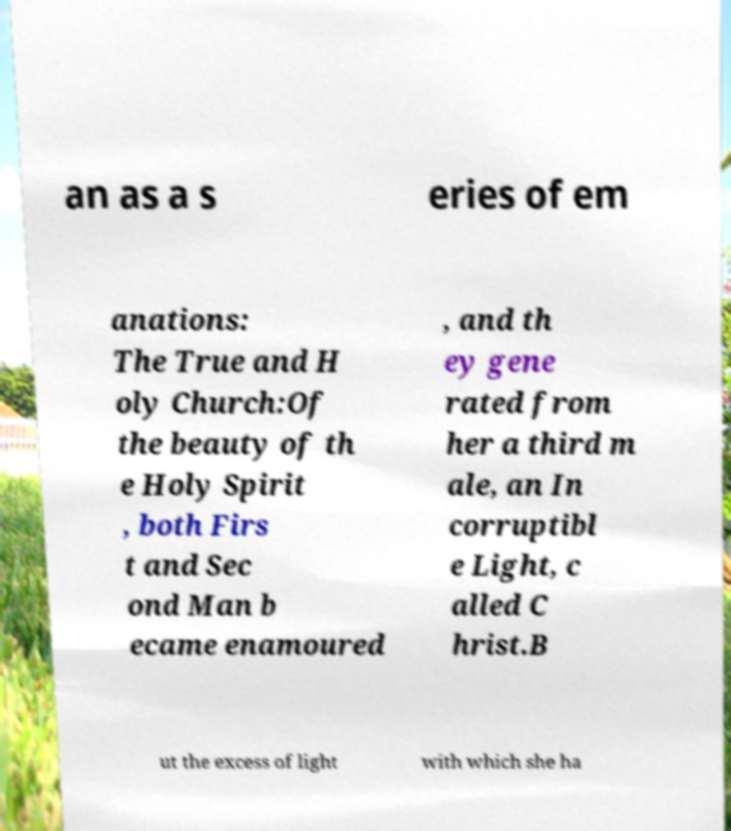Can you accurately transcribe the text from the provided image for me? an as a s eries of em anations: The True and H oly Church:Of the beauty of th e Holy Spirit , both Firs t and Sec ond Man b ecame enamoured , and th ey gene rated from her a third m ale, an In corruptibl e Light, c alled C hrist.B ut the excess of light with which she ha 